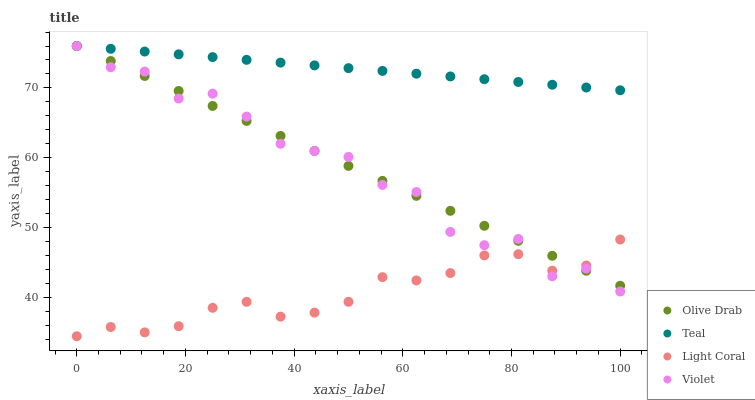Does Light Coral have the minimum area under the curve?
Answer yes or no. Yes. Does Teal have the maximum area under the curve?
Answer yes or no. Yes. Does Olive Drab have the minimum area under the curve?
Answer yes or no. No. Does Olive Drab have the maximum area under the curve?
Answer yes or no. No. Is Olive Drab the smoothest?
Answer yes or no. Yes. Is Violet the roughest?
Answer yes or no. Yes. Is Teal the smoothest?
Answer yes or no. No. Is Teal the roughest?
Answer yes or no. No. Does Light Coral have the lowest value?
Answer yes or no. Yes. Does Olive Drab have the lowest value?
Answer yes or no. No. Does Violet have the highest value?
Answer yes or no. Yes. Is Light Coral less than Teal?
Answer yes or no. Yes. Is Teal greater than Light Coral?
Answer yes or no. Yes. Does Teal intersect Violet?
Answer yes or no. Yes. Is Teal less than Violet?
Answer yes or no. No. Is Teal greater than Violet?
Answer yes or no. No. Does Light Coral intersect Teal?
Answer yes or no. No. 